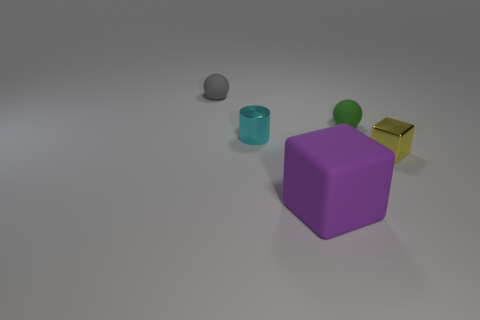There is a small shiny object behind the yellow cube; what shape is it?
Offer a terse response. Cylinder. Is there another yellow object made of the same material as the small yellow object?
Your response must be concise. No. Is the yellow block the same size as the purple matte cube?
Keep it short and to the point. No. How many blocks are either large purple matte objects or tiny yellow shiny things?
Ensure brevity in your answer.  2. How many big purple matte objects are the same shape as the small green rubber object?
Make the answer very short. 0. Is the number of purple cubes behind the cyan object greater than the number of green rubber spheres in front of the green ball?
Offer a very short reply. No. There is a small metal thing in front of the small cylinder; is it the same color as the cylinder?
Offer a terse response. No. The yellow object is what size?
Ensure brevity in your answer.  Small. There is a cylinder that is the same size as the yellow cube; what material is it?
Offer a terse response. Metal. What color is the rubber thing to the right of the big thing?
Keep it short and to the point. Green. 